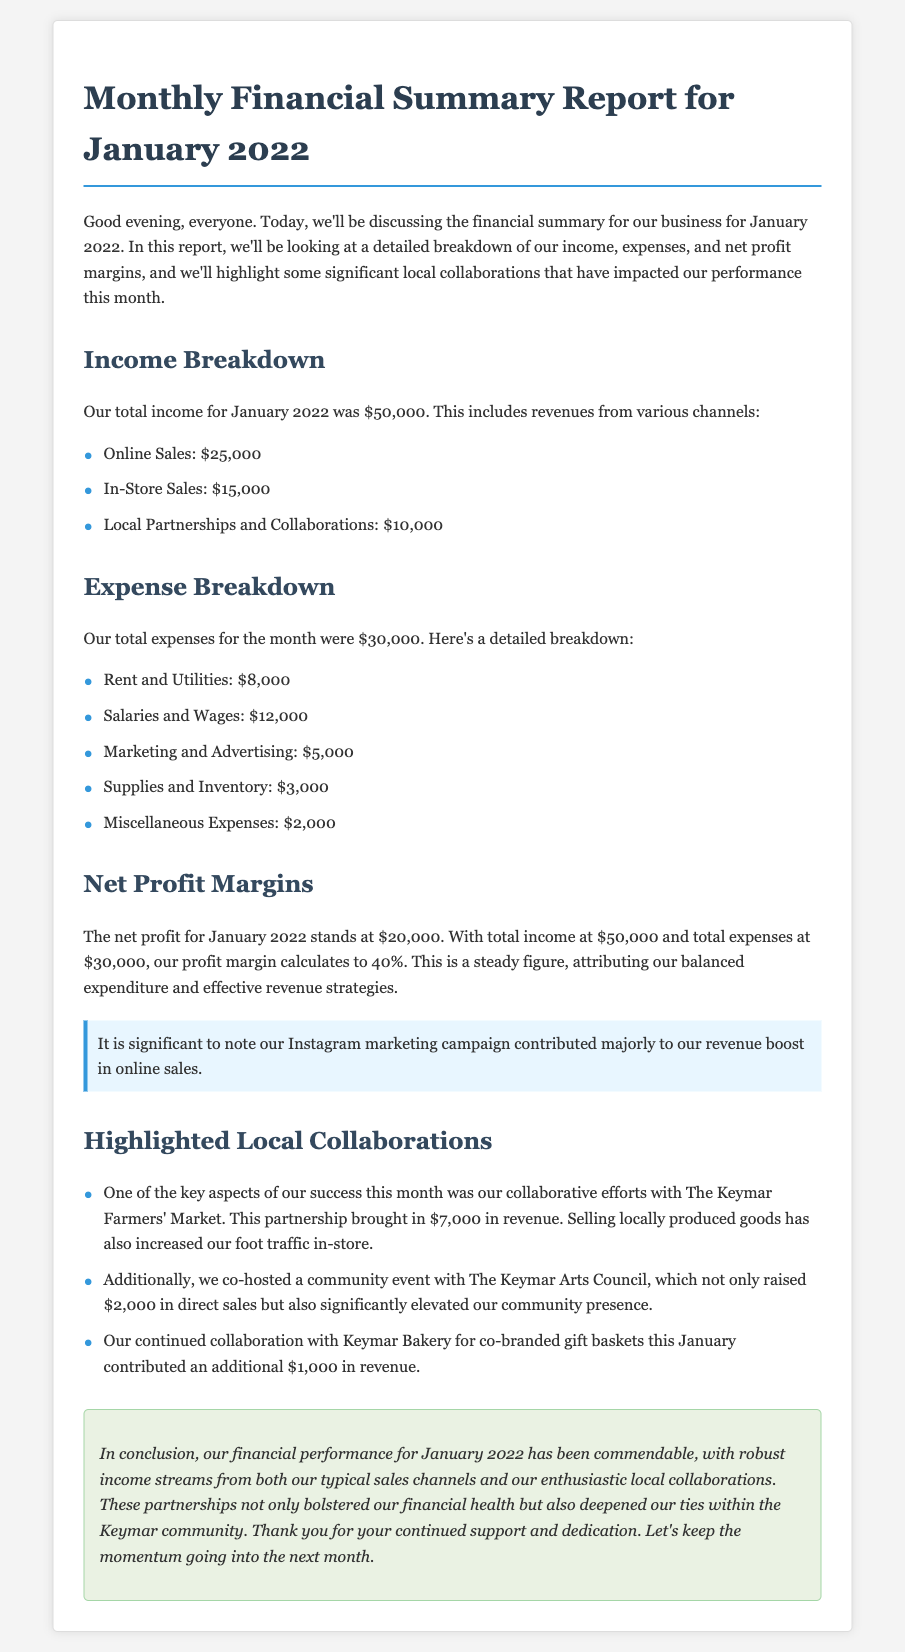what was the total income for January 2022? The total income is explicitly stated in the document as $50,000.
Answer: $50,000 how much revenue came from local partnerships and collaborations? The document outlines that revenue from local partnerships and collaborations was $10,000.
Answer: $10,000 what were the total expenses for the month? The total expenses are clearly mentioned in the document as $30,000.
Answer: $30,000 what was the net profit for January 2022? The document specifies that the net profit for January 2022 is $20,000.
Answer: $20,000 what is the profit margin percentage? The profit margin is derived from the total income and expenses, calculated as 40% as mentioned in the document.
Answer: 40% which local collaboration contributed the most revenue? According to the document, the collaboration with The Keymar Farmers' Market brought in the most revenue at $7,000.
Answer: $7,000 how much did the community event with The Keymar Arts Council raise in direct sales? The document states that the community event raised $2,000 in direct sales.
Answer: $2,000 how much revenue did the co-branded gift baskets with Keymar Bakery generate? The revenue from co-branded gift baskets with Keymar Bakery is listed as $1,000 in the document.
Answer: $1,000 what marketing campaign is highlighted as a contributor to the online sales revenue? The document highlights the Instagram marketing campaign as a significant contributor to online sales revenue.
Answer: Instagram marketing campaign 